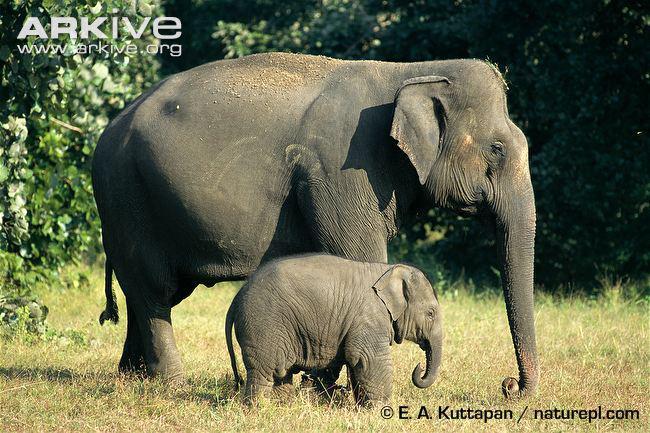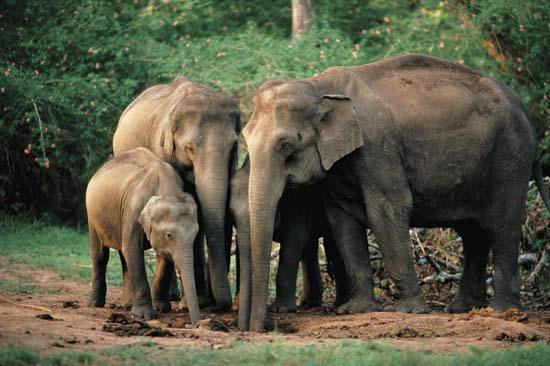The first image is the image on the left, the second image is the image on the right. For the images displayed, is the sentence "There are two elephants" factually correct? Answer yes or no. No. 